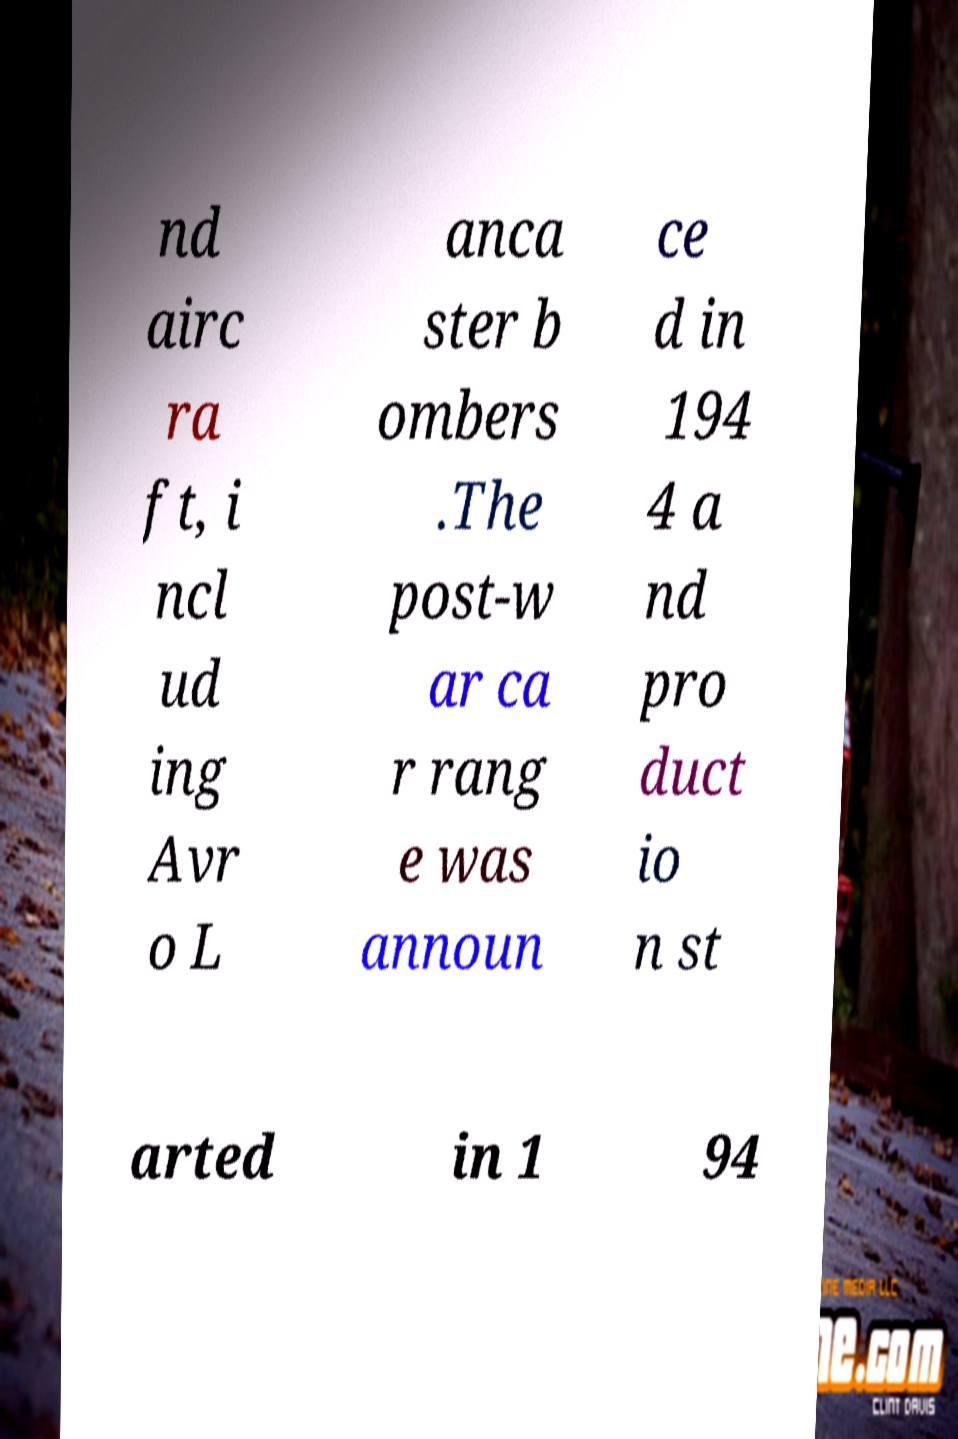Can you read and provide the text displayed in the image?This photo seems to have some interesting text. Can you extract and type it out for me? nd airc ra ft, i ncl ud ing Avr o L anca ster b ombers .The post-w ar ca r rang e was announ ce d in 194 4 a nd pro duct io n st arted in 1 94 